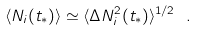<formula> <loc_0><loc_0><loc_500><loc_500>\langle N _ { i } ( t _ { * } ) \rangle \simeq \langle \Delta N _ { i } ^ { 2 } ( t _ { * } ) \rangle ^ { 1 / 2 } \ .</formula> 